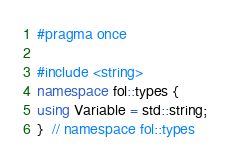<code> <loc_0><loc_0><loc_500><loc_500><_C++_>#pragma once

#include <string>
namespace fol::types {
using Variable = std::string;
}  // namespace fol::types
</code> 